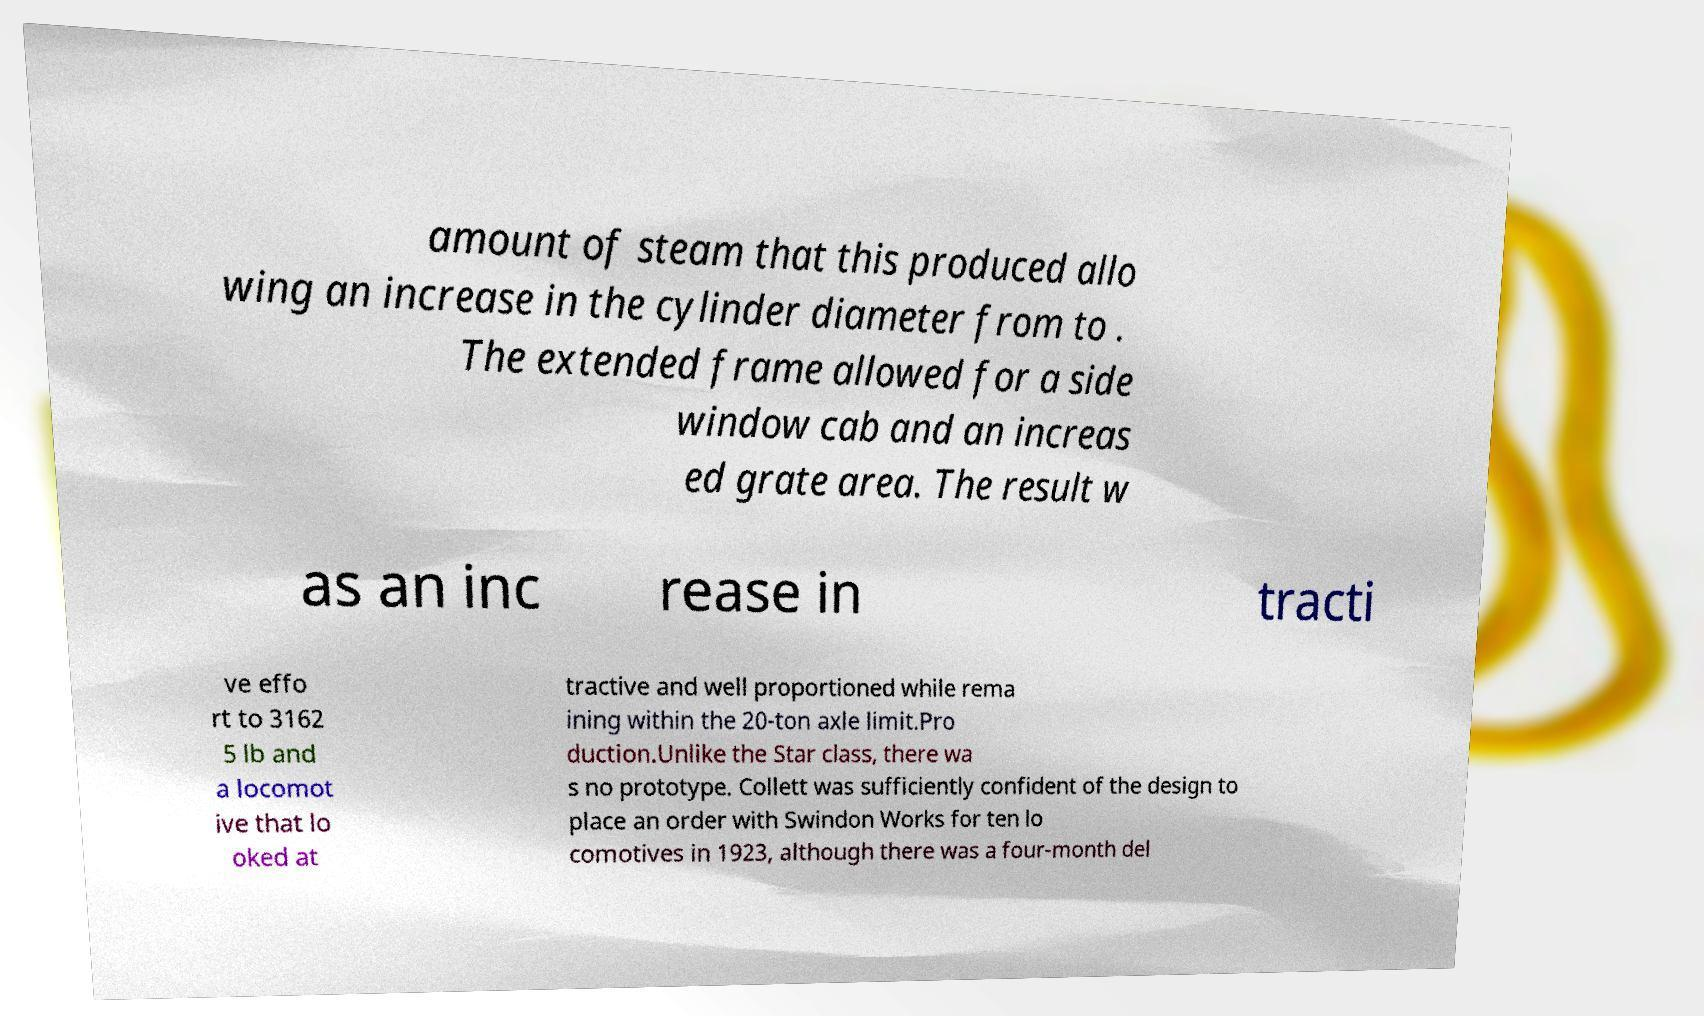For documentation purposes, I need the text within this image transcribed. Could you provide that? amount of steam that this produced allo wing an increase in the cylinder diameter from to . The extended frame allowed for a side window cab and an increas ed grate area. The result w as an inc rease in tracti ve effo rt to 3162 5 lb and a locomot ive that lo oked at tractive and well proportioned while rema ining within the 20-ton axle limit.Pro duction.Unlike the Star class, there wa s no prototype. Collett was sufficiently confident of the design to place an order with Swindon Works for ten lo comotives in 1923, although there was a four-month del 